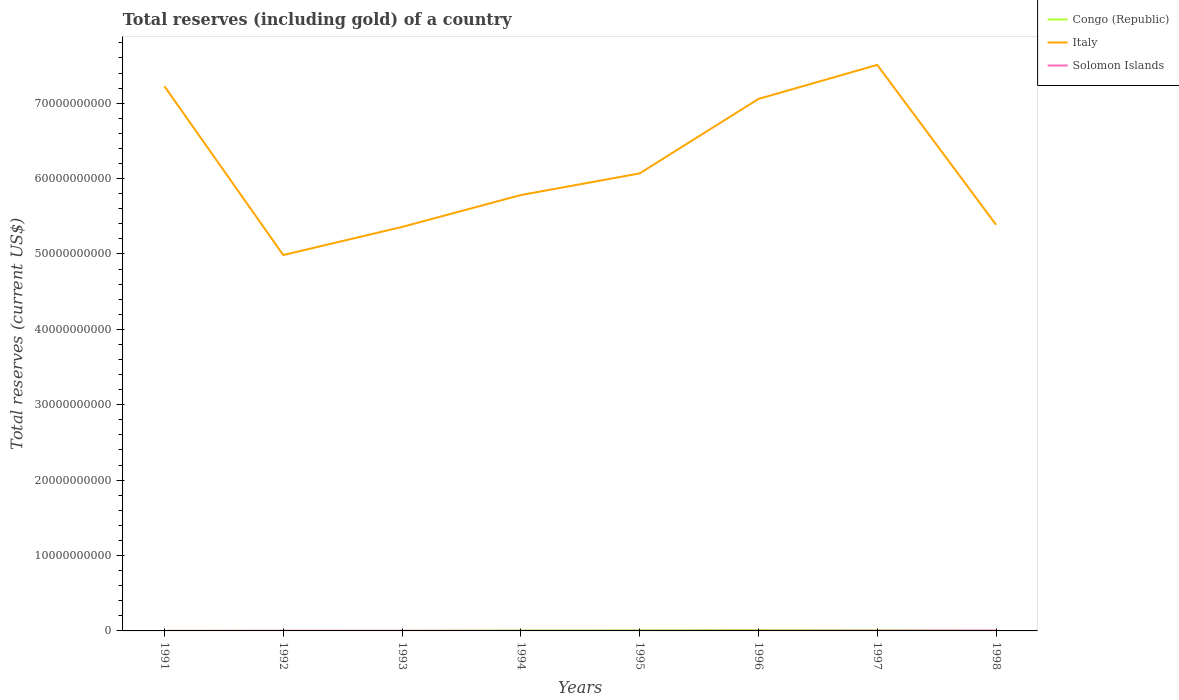Does the line corresponding to Italy intersect with the line corresponding to Solomon Islands?
Give a very brief answer. No. Is the number of lines equal to the number of legend labels?
Your answer should be compact. Yes. Across all years, what is the maximum total reserves (including gold) in Italy?
Your response must be concise. 4.99e+1. In which year was the total reserves (including gold) in Italy maximum?
Keep it short and to the point. 1992. What is the total total reserves (including gold) in Congo (Republic) in the graph?
Your answer should be very brief. -8.52e+06. What is the difference between the highest and the second highest total reserves (including gold) in Italy?
Provide a succinct answer. 2.52e+1. Is the total reserves (including gold) in Solomon Islands strictly greater than the total reserves (including gold) in Italy over the years?
Provide a short and direct response. Yes. How many lines are there?
Your answer should be compact. 3. Are the values on the major ticks of Y-axis written in scientific E-notation?
Provide a succinct answer. No. Where does the legend appear in the graph?
Offer a terse response. Top right. How many legend labels are there?
Your answer should be compact. 3. How are the legend labels stacked?
Keep it short and to the point. Vertical. What is the title of the graph?
Provide a short and direct response. Total reserves (including gold) of a country. What is the label or title of the X-axis?
Give a very brief answer. Years. What is the label or title of the Y-axis?
Your answer should be very brief. Total reserves (current US$). What is the Total reserves (current US$) of Congo (Republic) in 1991?
Offer a very short reply. 8.69e+06. What is the Total reserves (current US$) in Italy in 1991?
Your answer should be compact. 7.23e+1. What is the Total reserves (current US$) in Solomon Islands in 1991?
Offer a terse response. 8.54e+06. What is the Total reserves (current US$) of Congo (Republic) in 1992?
Your answer should be very brief. 7.71e+06. What is the Total reserves (current US$) of Italy in 1992?
Offer a very short reply. 4.99e+1. What is the Total reserves (current US$) of Solomon Islands in 1992?
Your response must be concise. 2.35e+07. What is the Total reserves (current US$) in Congo (Republic) in 1993?
Your answer should be compact. 5.68e+06. What is the Total reserves (current US$) of Italy in 1993?
Keep it short and to the point. 5.36e+1. What is the Total reserves (current US$) in Solomon Islands in 1993?
Offer a terse response. 2.01e+07. What is the Total reserves (current US$) in Congo (Republic) in 1994?
Your answer should be very brief. 5.46e+07. What is the Total reserves (current US$) in Italy in 1994?
Your answer should be compact. 5.78e+1. What is the Total reserves (current US$) of Solomon Islands in 1994?
Make the answer very short. 1.74e+07. What is the Total reserves (current US$) in Congo (Republic) in 1995?
Offer a terse response. 6.36e+07. What is the Total reserves (current US$) in Italy in 1995?
Give a very brief answer. 6.07e+1. What is the Total reserves (current US$) in Solomon Islands in 1995?
Your response must be concise. 1.59e+07. What is the Total reserves (current US$) of Congo (Republic) in 1996?
Your response must be concise. 9.51e+07. What is the Total reserves (current US$) in Italy in 1996?
Your response must be concise. 7.06e+1. What is the Total reserves (current US$) in Solomon Islands in 1996?
Provide a short and direct response. 3.26e+07. What is the Total reserves (current US$) of Congo (Republic) in 1997?
Give a very brief answer. 6.31e+07. What is the Total reserves (current US$) in Italy in 1997?
Provide a succinct answer. 7.51e+1. What is the Total reserves (current US$) of Solomon Islands in 1997?
Ensure brevity in your answer.  3.63e+07. What is the Total reserves (current US$) of Congo (Republic) in 1998?
Offer a very short reply. 4.04e+06. What is the Total reserves (current US$) in Italy in 1998?
Your answer should be compact. 5.39e+1. What is the Total reserves (current US$) of Solomon Islands in 1998?
Your answer should be very brief. 4.90e+07. Across all years, what is the maximum Total reserves (current US$) of Congo (Republic)?
Offer a terse response. 9.51e+07. Across all years, what is the maximum Total reserves (current US$) in Italy?
Ensure brevity in your answer.  7.51e+1. Across all years, what is the maximum Total reserves (current US$) in Solomon Islands?
Provide a short and direct response. 4.90e+07. Across all years, what is the minimum Total reserves (current US$) in Congo (Republic)?
Provide a short and direct response. 4.04e+06. Across all years, what is the minimum Total reserves (current US$) of Italy?
Provide a succinct answer. 4.99e+1. Across all years, what is the minimum Total reserves (current US$) of Solomon Islands?
Your answer should be compact. 8.54e+06. What is the total Total reserves (current US$) in Congo (Republic) in the graph?
Make the answer very short. 3.03e+08. What is the total Total reserves (current US$) in Italy in the graph?
Offer a terse response. 4.94e+11. What is the total Total reserves (current US$) in Solomon Islands in the graph?
Ensure brevity in your answer.  2.03e+08. What is the difference between the Total reserves (current US$) in Congo (Republic) in 1991 and that in 1992?
Provide a short and direct response. 9.80e+05. What is the difference between the Total reserves (current US$) in Italy in 1991 and that in 1992?
Make the answer very short. 2.24e+1. What is the difference between the Total reserves (current US$) of Solomon Islands in 1991 and that in 1992?
Provide a short and direct response. -1.50e+07. What is the difference between the Total reserves (current US$) of Congo (Republic) in 1991 and that in 1993?
Make the answer very short. 3.01e+06. What is the difference between the Total reserves (current US$) in Italy in 1991 and that in 1993?
Give a very brief answer. 1.87e+1. What is the difference between the Total reserves (current US$) in Solomon Islands in 1991 and that in 1993?
Give a very brief answer. -1.15e+07. What is the difference between the Total reserves (current US$) in Congo (Republic) in 1991 and that in 1994?
Your answer should be very brief. -4.59e+07. What is the difference between the Total reserves (current US$) of Italy in 1991 and that in 1994?
Your answer should be compact. 1.44e+1. What is the difference between the Total reserves (current US$) in Solomon Islands in 1991 and that in 1994?
Provide a short and direct response. -8.88e+06. What is the difference between the Total reserves (current US$) of Congo (Republic) in 1991 and that in 1995?
Provide a succinct answer. -5.49e+07. What is the difference between the Total reserves (current US$) of Italy in 1991 and that in 1995?
Make the answer very short. 1.16e+1. What is the difference between the Total reserves (current US$) of Solomon Islands in 1991 and that in 1995?
Offer a terse response. -7.36e+06. What is the difference between the Total reserves (current US$) in Congo (Republic) in 1991 and that in 1996?
Offer a very short reply. -8.64e+07. What is the difference between the Total reserves (current US$) in Italy in 1991 and that in 1996?
Ensure brevity in your answer.  1.69e+09. What is the difference between the Total reserves (current US$) of Solomon Islands in 1991 and that in 1996?
Keep it short and to the point. -2.40e+07. What is the difference between the Total reserves (current US$) in Congo (Republic) in 1991 and that in 1997?
Provide a succinct answer. -5.45e+07. What is the difference between the Total reserves (current US$) of Italy in 1991 and that in 1997?
Provide a short and direct response. -2.83e+09. What is the difference between the Total reserves (current US$) of Solomon Islands in 1991 and that in 1997?
Your answer should be very brief. -2.78e+07. What is the difference between the Total reserves (current US$) in Congo (Republic) in 1991 and that in 1998?
Offer a terse response. 4.65e+06. What is the difference between the Total reserves (current US$) of Italy in 1991 and that in 1998?
Make the answer very short. 1.84e+1. What is the difference between the Total reserves (current US$) in Solomon Islands in 1991 and that in 1998?
Your response must be concise. -4.05e+07. What is the difference between the Total reserves (current US$) in Congo (Republic) in 1992 and that in 1993?
Your answer should be compact. 2.03e+06. What is the difference between the Total reserves (current US$) of Italy in 1992 and that in 1993?
Your answer should be very brief. -3.73e+09. What is the difference between the Total reserves (current US$) in Solomon Islands in 1992 and that in 1993?
Offer a terse response. 3.43e+06. What is the difference between the Total reserves (current US$) in Congo (Republic) in 1992 and that in 1994?
Your answer should be compact. -4.69e+07. What is the difference between the Total reserves (current US$) in Italy in 1992 and that in 1994?
Your answer should be very brief. -7.96e+09. What is the difference between the Total reserves (current US$) of Solomon Islands in 1992 and that in 1994?
Offer a very short reply. 6.08e+06. What is the difference between the Total reserves (current US$) of Congo (Republic) in 1992 and that in 1995?
Provide a short and direct response. -5.59e+07. What is the difference between the Total reserves (current US$) in Italy in 1992 and that in 1995?
Provide a succinct answer. -1.08e+1. What is the difference between the Total reserves (current US$) of Solomon Islands in 1992 and that in 1995?
Offer a very short reply. 7.59e+06. What is the difference between the Total reserves (current US$) in Congo (Republic) in 1992 and that in 1996?
Your answer should be very brief. -8.74e+07. What is the difference between the Total reserves (current US$) in Italy in 1992 and that in 1996?
Keep it short and to the point. -2.07e+1. What is the difference between the Total reserves (current US$) of Solomon Islands in 1992 and that in 1996?
Give a very brief answer. -9.09e+06. What is the difference between the Total reserves (current US$) of Congo (Republic) in 1992 and that in 1997?
Offer a terse response. -5.54e+07. What is the difference between the Total reserves (current US$) of Italy in 1992 and that in 1997?
Make the answer very short. -2.52e+1. What is the difference between the Total reserves (current US$) of Solomon Islands in 1992 and that in 1997?
Offer a very short reply. -1.28e+07. What is the difference between the Total reserves (current US$) of Congo (Republic) in 1992 and that in 1998?
Make the answer very short. 3.67e+06. What is the difference between the Total reserves (current US$) in Italy in 1992 and that in 1998?
Your answer should be very brief. -4.02e+09. What is the difference between the Total reserves (current US$) of Solomon Islands in 1992 and that in 1998?
Offer a terse response. -2.55e+07. What is the difference between the Total reserves (current US$) of Congo (Republic) in 1993 and that in 1994?
Keep it short and to the point. -4.89e+07. What is the difference between the Total reserves (current US$) of Italy in 1993 and that in 1994?
Ensure brevity in your answer.  -4.23e+09. What is the difference between the Total reserves (current US$) of Solomon Islands in 1993 and that in 1994?
Give a very brief answer. 2.65e+06. What is the difference between the Total reserves (current US$) of Congo (Republic) in 1993 and that in 1995?
Your response must be concise. -5.79e+07. What is the difference between the Total reserves (current US$) in Italy in 1993 and that in 1995?
Offer a terse response. -7.10e+09. What is the difference between the Total reserves (current US$) in Solomon Islands in 1993 and that in 1995?
Give a very brief answer. 4.16e+06. What is the difference between the Total reserves (current US$) in Congo (Republic) in 1993 and that in 1996?
Keep it short and to the point. -8.94e+07. What is the difference between the Total reserves (current US$) of Italy in 1993 and that in 1996?
Your answer should be compact. -1.70e+1. What is the difference between the Total reserves (current US$) in Solomon Islands in 1993 and that in 1996?
Ensure brevity in your answer.  -1.25e+07. What is the difference between the Total reserves (current US$) in Congo (Republic) in 1993 and that in 1997?
Your answer should be compact. -5.75e+07. What is the difference between the Total reserves (current US$) in Italy in 1993 and that in 1997?
Your response must be concise. -2.15e+1. What is the difference between the Total reserves (current US$) of Solomon Islands in 1993 and that in 1997?
Your response must be concise. -1.63e+07. What is the difference between the Total reserves (current US$) in Congo (Republic) in 1993 and that in 1998?
Offer a very short reply. 1.64e+06. What is the difference between the Total reserves (current US$) of Italy in 1993 and that in 1998?
Your answer should be compact. -2.90e+08. What is the difference between the Total reserves (current US$) in Solomon Islands in 1993 and that in 1998?
Provide a short and direct response. -2.90e+07. What is the difference between the Total reserves (current US$) of Congo (Republic) in 1994 and that in 1995?
Give a very brief answer. -8.98e+06. What is the difference between the Total reserves (current US$) of Italy in 1994 and that in 1995?
Ensure brevity in your answer.  -2.87e+09. What is the difference between the Total reserves (current US$) of Solomon Islands in 1994 and that in 1995?
Provide a short and direct response. 1.51e+06. What is the difference between the Total reserves (current US$) in Congo (Republic) in 1994 and that in 1996?
Offer a very short reply. -4.05e+07. What is the difference between the Total reserves (current US$) of Italy in 1994 and that in 1996?
Offer a very short reply. -1.27e+1. What is the difference between the Total reserves (current US$) in Solomon Islands in 1994 and that in 1996?
Provide a short and direct response. -1.52e+07. What is the difference between the Total reserves (current US$) in Congo (Republic) in 1994 and that in 1997?
Offer a terse response. -8.52e+06. What is the difference between the Total reserves (current US$) of Italy in 1994 and that in 1997?
Keep it short and to the point. -1.73e+1. What is the difference between the Total reserves (current US$) of Solomon Islands in 1994 and that in 1997?
Offer a very short reply. -1.89e+07. What is the difference between the Total reserves (current US$) in Congo (Republic) in 1994 and that in 1998?
Provide a short and direct response. 5.06e+07. What is the difference between the Total reserves (current US$) of Italy in 1994 and that in 1998?
Keep it short and to the point. 3.94e+09. What is the difference between the Total reserves (current US$) of Solomon Islands in 1994 and that in 1998?
Your answer should be compact. -3.16e+07. What is the difference between the Total reserves (current US$) of Congo (Republic) in 1995 and that in 1996?
Your answer should be compact. -3.15e+07. What is the difference between the Total reserves (current US$) in Italy in 1995 and that in 1996?
Offer a terse response. -9.88e+09. What is the difference between the Total reserves (current US$) in Solomon Islands in 1995 and that in 1996?
Provide a succinct answer. -1.67e+07. What is the difference between the Total reserves (current US$) in Congo (Republic) in 1995 and that in 1997?
Your answer should be very brief. 4.56e+05. What is the difference between the Total reserves (current US$) of Italy in 1995 and that in 1997?
Give a very brief answer. -1.44e+1. What is the difference between the Total reserves (current US$) of Solomon Islands in 1995 and that in 1997?
Your response must be concise. -2.04e+07. What is the difference between the Total reserves (current US$) in Congo (Republic) in 1995 and that in 1998?
Your response must be concise. 5.96e+07. What is the difference between the Total reserves (current US$) in Italy in 1995 and that in 1998?
Your response must be concise. 6.81e+09. What is the difference between the Total reserves (current US$) of Solomon Islands in 1995 and that in 1998?
Offer a very short reply. -3.31e+07. What is the difference between the Total reserves (current US$) of Congo (Republic) in 1996 and that in 1997?
Keep it short and to the point. 3.20e+07. What is the difference between the Total reserves (current US$) in Italy in 1996 and that in 1997?
Offer a very short reply. -4.52e+09. What is the difference between the Total reserves (current US$) of Solomon Islands in 1996 and that in 1997?
Make the answer very short. -3.76e+06. What is the difference between the Total reserves (current US$) in Congo (Republic) in 1996 and that in 1998?
Offer a very short reply. 9.11e+07. What is the difference between the Total reserves (current US$) of Italy in 1996 and that in 1998?
Your answer should be very brief. 1.67e+1. What is the difference between the Total reserves (current US$) in Solomon Islands in 1996 and that in 1998?
Keep it short and to the point. -1.65e+07. What is the difference between the Total reserves (current US$) in Congo (Republic) in 1997 and that in 1998?
Provide a succinct answer. 5.91e+07. What is the difference between the Total reserves (current US$) of Italy in 1997 and that in 1998?
Ensure brevity in your answer.  2.12e+1. What is the difference between the Total reserves (current US$) of Solomon Islands in 1997 and that in 1998?
Your response must be concise. -1.27e+07. What is the difference between the Total reserves (current US$) in Congo (Republic) in 1991 and the Total reserves (current US$) in Italy in 1992?
Offer a very short reply. -4.99e+1. What is the difference between the Total reserves (current US$) in Congo (Republic) in 1991 and the Total reserves (current US$) in Solomon Islands in 1992?
Provide a short and direct response. -1.48e+07. What is the difference between the Total reserves (current US$) in Italy in 1991 and the Total reserves (current US$) in Solomon Islands in 1992?
Your answer should be compact. 7.22e+1. What is the difference between the Total reserves (current US$) in Congo (Republic) in 1991 and the Total reserves (current US$) in Italy in 1993?
Offer a terse response. -5.36e+1. What is the difference between the Total reserves (current US$) of Congo (Republic) in 1991 and the Total reserves (current US$) of Solomon Islands in 1993?
Ensure brevity in your answer.  -1.14e+07. What is the difference between the Total reserves (current US$) in Italy in 1991 and the Total reserves (current US$) in Solomon Islands in 1993?
Keep it short and to the point. 7.22e+1. What is the difference between the Total reserves (current US$) in Congo (Republic) in 1991 and the Total reserves (current US$) in Italy in 1994?
Your response must be concise. -5.78e+1. What is the difference between the Total reserves (current US$) in Congo (Republic) in 1991 and the Total reserves (current US$) in Solomon Islands in 1994?
Give a very brief answer. -8.72e+06. What is the difference between the Total reserves (current US$) of Italy in 1991 and the Total reserves (current US$) of Solomon Islands in 1994?
Your answer should be compact. 7.22e+1. What is the difference between the Total reserves (current US$) of Congo (Republic) in 1991 and the Total reserves (current US$) of Italy in 1995?
Provide a succinct answer. -6.07e+1. What is the difference between the Total reserves (current US$) of Congo (Republic) in 1991 and the Total reserves (current US$) of Solomon Islands in 1995?
Offer a terse response. -7.21e+06. What is the difference between the Total reserves (current US$) in Italy in 1991 and the Total reserves (current US$) in Solomon Islands in 1995?
Provide a succinct answer. 7.22e+1. What is the difference between the Total reserves (current US$) in Congo (Republic) in 1991 and the Total reserves (current US$) in Italy in 1996?
Make the answer very short. -7.06e+1. What is the difference between the Total reserves (current US$) in Congo (Republic) in 1991 and the Total reserves (current US$) in Solomon Islands in 1996?
Your response must be concise. -2.39e+07. What is the difference between the Total reserves (current US$) in Italy in 1991 and the Total reserves (current US$) in Solomon Islands in 1996?
Your answer should be very brief. 7.22e+1. What is the difference between the Total reserves (current US$) in Congo (Republic) in 1991 and the Total reserves (current US$) in Italy in 1997?
Give a very brief answer. -7.51e+1. What is the difference between the Total reserves (current US$) in Congo (Republic) in 1991 and the Total reserves (current US$) in Solomon Islands in 1997?
Your answer should be compact. -2.76e+07. What is the difference between the Total reserves (current US$) of Italy in 1991 and the Total reserves (current US$) of Solomon Islands in 1997?
Provide a succinct answer. 7.22e+1. What is the difference between the Total reserves (current US$) of Congo (Republic) in 1991 and the Total reserves (current US$) of Italy in 1998?
Your response must be concise. -5.39e+1. What is the difference between the Total reserves (current US$) in Congo (Republic) in 1991 and the Total reserves (current US$) in Solomon Islands in 1998?
Keep it short and to the point. -4.03e+07. What is the difference between the Total reserves (current US$) of Italy in 1991 and the Total reserves (current US$) of Solomon Islands in 1998?
Provide a succinct answer. 7.22e+1. What is the difference between the Total reserves (current US$) of Congo (Republic) in 1992 and the Total reserves (current US$) of Italy in 1993?
Keep it short and to the point. -5.36e+1. What is the difference between the Total reserves (current US$) in Congo (Republic) in 1992 and the Total reserves (current US$) in Solomon Islands in 1993?
Your response must be concise. -1.24e+07. What is the difference between the Total reserves (current US$) of Italy in 1992 and the Total reserves (current US$) of Solomon Islands in 1993?
Ensure brevity in your answer.  4.98e+1. What is the difference between the Total reserves (current US$) of Congo (Republic) in 1992 and the Total reserves (current US$) of Italy in 1994?
Your response must be concise. -5.78e+1. What is the difference between the Total reserves (current US$) in Congo (Republic) in 1992 and the Total reserves (current US$) in Solomon Islands in 1994?
Your response must be concise. -9.70e+06. What is the difference between the Total reserves (current US$) of Italy in 1992 and the Total reserves (current US$) of Solomon Islands in 1994?
Offer a very short reply. 4.98e+1. What is the difference between the Total reserves (current US$) of Congo (Republic) in 1992 and the Total reserves (current US$) of Italy in 1995?
Offer a terse response. -6.07e+1. What is the difference between the Total reserves (current US$) in Congo (Republic) in 1992 and the Total reserves (current US$) in Solomon Islands in 1995?
Ensure brevity in your answer.  -8.19e+06. What is the difference between the Total reserves (current US$) of Italy in 1992 and the Total reserves (current US$) of Solomon Islands in 1995?
Your response must be concise. 4.98e+1. What is the difference between the Total reserves (current US$) of Congo (Republic) in 1992 and the Total reserves (current US$) of Italy in 1996?
Make the answer very short. -7.06e+1. What is the difference between the Total reserves (current US$) of Congo (Republic) in 1992 and the Total reserves (current US$) of Solomon Islands in 1996?
Make the answer very short. -2.49e+07. What is the difference between the Total reserves (current US$) of Italy in 1992 and the Total reserves (current US$) of Solomon Islands in 1996?
Your answer should be very brief. 4.98e+1. What is the difference between the Total reserves (current US$) of Congo (Republic) in 1992 and the Total reserves (current US$) of Italy in 1997?
Keep it short and to the point. -7.51e+1. What is the difference between the Total reserves (current US$) of Congo (Republic) in 1992 and the Total reserves (current US$) of Solomon Islands in 1997?
Keep it short and to the point. -2.86e+07. What is the difference between the Total reserves (current US$) in Italy in 1992 and the Total reserves (current US$) in Solomon Islands in 1997?
Offer a very short reply. 4.98e+1. What is the difference between the Total reserves (current US$) of Congo (Republic) in 1992 and the Total reserves (current US$) of Italy in 1998?
Ensure brevity in your answer.  -5.39e+1. What is the difference between the Total reserves (current US$) in Congo (Republic) in 1992 and the Total reserves (current US$) in Solomon Islands in 1998?
Make the answer very short. -4.13e+07. What is the difference between the Total reserves (current US$) of Italy in 1992 and the Total reserves (current US$) of Solomon Islands in 1998?
Provide a short and direct response. 4.98e+1. What is the difference between the Total reserves (current US$) in Congo (Republic) in 1993 and the Total reserves (current US$) in Italy in 1994?
Your response must be concise. -5.78e+1. What is the difference between the Total reserves (current US$) in Congo (Republic) in 1993 and the Total reserves (current US$) in Solomon Islands in 1994?
Provide a short and direct response. -1.17e+07. What is the difference between the Total reserves (current US$) of Italy in 1993 and the Total reserves (current US$) of Solomon Islands in 1994?
Offer a very short reply. 5.36e+1. What is the difference between the Total reserves (current US$) in Congo (Republic) in 1993 and the Total reserves (current US$) in Italy in 1995?
Provide a short and direct response. -6.07e+1. What is the difference between the Total reserves (current US$) in Congo (Republic) in 1993 and the Total reserves (current US$) in Solomon Islands in 1995?
Your answer should be very brief. -1.02e+07. What is the difference between the Total reserves (current US$) in Italy in 1993 and the Total reserves (current US$) in Solomon Islands in 1995?
Your answer should be compact. 5.36e+1. What is the difference between the Total reserves (current US$) of Congo (Republic) in 1993 and the Total reserves (current US$) of Italy in 1996?
Your response must be concise. -7.06e+1. What is the difference between the Total reserves (current US$) of Congo (Republic) in 1993 and the Total reserves (current US$) of Solomon Islands in 1996?
Provide a short and direct response. -2.69e+07. What is the difference between the Total reserves (current US$) of Italy in 1993 and the Total reserves (current US$) of Solomon Islands in 1996?
Your answer should be compact. 5.36e+1. What is the difference between the Total reserves (current US$) in Congo (Republic) in 1993 and the Total reserves (current US$) in Italy in 1997?
Make the answer very short. -7.51e+1. What is the difference between the Total reserves (current US$) in Congo (Republic) in 1993 and the Total reserves (current US$) in Solomon Islands in 1997?
Offer a very short reply. -3.07e+07. What is the difference between the Total reserves (current US$) of Italy in 1993 and the Total reserves (current US$) of Solomon Islands in 1997?
Your answer should be very brief. 5.36e+1. What is the difference between the Total reserves (current US$) of Congo (Republic) in 1993 and the Total reserves (current US$) of Italy in 1998?
Provide a short and direct response. -5.39e+1. What is the difference between the Total reserves (current US$) in Congo (Republic) in 1993 and the Total reserves (current US$) in Solomon Islands in 1998?
Your response must be concise. -4.34e+07. What is the difference between the Total reserves (current US$) of Italy in 1993 and the Total reserves (current US$) of Solomon Islands in 1998?
Provide a short and direct response. 5.35e+1. What is the difference between the Total reserves (current US$) in Congo (Republic) in 1994 and the Total reserves (current US$) in Italy in 1995?
Offer a terse response. -6.06e+1. What is the difference between the Total reserves (current US$) of Congo (Republic) in 1994 and the Total reserves (current US$) of Solomon Islands in 1995?
Ensure brevity in your answer.  3.87e+07. What is the difference between the Total reserves (current US$) in Italy in 1994 and the Total reserves (current US$) in Solomon Islands in 1995?
Your response must be concise. 5.78e+1. What is the difference between the Total reserves (current US$) in Congo (Republic) in 1994 and the Total reserves (current US$) in Italy in 1996?
Offer a very short reply. -7.05e+1. What is the difference between the Total reserves (current US$) in Congo (Republic) in 1994 and the Total reserves (current US$) in Solomon Islands in 1996?
Offer a very short reply. 2.20e+07. What is the difference between the Total reserves (current US$) in Italy in 1994 and the Total reserves (current US$) in Solomon Islands in 1996?
Offer a very short reply. 5.78e+1. What is the difference between the Total reserves (current US$) of Congo (Republic) in 1994 and the Total reserves (current US$) of Italy in 1997?
Offer a very short reply. -7.50e+1. What is the difference between the Total reserves (current US$) of Congo (Republic) in 1994 and the Total reserves (current US$) of Solomon Islands in 1997?
Offer a very short reply. 1.83e+07. What is the difference between the Total reserves (current US$) of Italy in 1994 and the Total reserves (current US$) of Solomon Islands in 1997?
Give a very brief answer. 5.78e+1. What is the difference between the Total reserves (current US$) in Congo (Republic) in 1994 and the Total reserves (current US$) in Italy in 1998?
Provide a short and direct response. -5.38e+1. What is the difference between the Total reserves (current US$) of Congo (Republic) in 1994 and the Total reserves (current US$) of Solomon Islands in 1998?
Your response must be concise. 5.59e+06. What is the difference between the Total reserves (current US$) in Italy in 1994 and the Total reserves (current US$) in Solomon Islands in 1998?
Provide a succinct answer. 5.78e+1. What is the difference between the Total reserves (current US$) in Congo (Republic) in 1995 and the Total reserves (current US$) in Italy in 1996?
Keep it short and to the point. -7.05e+1. What is the difference between the Total reserves (current US$) in Congo (Republic) in 1995 and the Total reserves (current US$) in Solomon Islands in 1996?
Give a very brief answer. 3.10e+07. What is the difference between the Total reserves (current US$) of Italy in 1995 and the Total reserves (current US$) of Solomon Islands in 1996?
Ensure brevity in your answer.  6.07e+1. What is the difference between the Total reserves (current US$) of Congo (Republic) in 1995 and the Total reserves (current US$) of Italy in 1997?
Make the answer very short. -7.50e+1. What is the difference between the Total reserves (current US$) of Congo (Republic) in 1995 and the Total reserves (current US$) of Solomon Islands in 1997?
Your response must be concise. 2.73e+07. What is the difference between the Total reserves (current US$) of Italy in 1995 and the Total reserves (current US$) of Solomon Islands in 1997?
Provide a short and direct response. 6.07e+1. What is the difference between the Total reserves (current US$) of Congo (Republic) in 1995 and the Total reserves (current US$) of Italy in 1998?
Your response must be concise. -5.38e+1. What is the difference between the Total reserves (current US$) in Congo (Republic) in 1995 and the Total reserves (current US$) in Solomon Islands in 1998?
Ensure brevity in your answer.  1.46e+07. What is the difference between the Total reserves (current US$) in Italy in 1995 and the Total reserves (current US$) in Solomon Islands in 1998?
Ensure brevity in your answer.  6.06e+1. What is the difference between the Total reserves (current US$) of Congo (Republic) in 1996 and the Total reserves (current US$) of Italy in 1997?
Your answer should be very brief. -7.50e+1. What is the difference between the Total reserves (current US$) in Congo (Republic) in 1996 and the Total reserves (current US$) in Solomon Islands in 1997?
Ensure brevity in your answer.  5.88e+07. What is the difference between the Total reserves (current US$) in Italy in 1996 and the Total reserves (current US$) in Solomon Islands in 1997?
Your answer should be compact. 7.05e+1. What is the difference between the Total reserves (current US$) in Congo (Republic) in 1996 and the Total reserves (current US$) in Italy in 1998?
Provide a succinct answer. -5.38e+1. What is the difference between the Total reserves (current US$) of Congo (Republic) in 1996 and the Total reserves (current US$) of Solomon Islands in 1998?
Give a very brief answer. 4.61e+07. What is the difference between the Total reserves (current US$) in Italy in 1996 and the Total reserves (current US$) in Solomon Islands in 1998?
Give a very brief answer. 7.05e+1. What is the difference between the Total reserves (current US$) of Congo (Republic) in 1997 and the Total reserves (current US$) of Italy in 1998?
Make the answer very short. -5.38e+1. What is the difference between the Total reserves (current US$) of Congo (Republic) in 1997 and the Total reserves (current US$) of Solomon Islands in 1998?
Provide a succinct answer. 1.41e+07. What is the difference between the Total reserves (current US$) of Italy in 1997 and the Total reserves (current US$) of Solomon Islands in 1998?
Keep it short and to the point. 7.50e+1. What is the average Total reserves (current US$) of Congo (Republic) per year?
Your answer should be compact. 3.78e+07. What is the average Total reserves (current US$) of Italy per year?
Offer a very short reply. 6.17e+1. What is the average Total reserves (current US$) of Solomon Islands per year?
Provide a succinct answer. 2.54e+07. In the year 1991, what is the difference between the Total reserves (current US$) in Congo (Republic) and Total reserves (current US$) in Italy?
Your answer should be compact. -7.22e+1. In the year 1991, what is the difference between the Total reserves (current US$) in Congo (Republic) and Total reserves (current US$) in Solomon Islands?
Offer a terse response. 1.52e+05. In the year 1991, what is the difference between the Total reserves (current US$) in Italy and Total reserves (current US$) in Solomon Islands?
Your answer should be compact. 7.22e+1. In the year 1992, what is the difference between the Total reserves (current US$) in Congo (Republic) and Total reserves (current US$) in Italy?
Ensure brevity in your answer.  -4.99e+1. In the year 1992, what is the difference between the Total reserves (current US$) of Congo (Republic) and Total reserves (current US$) of Solomon Islands?
Keep it short and to the point. -1.58e+07. In the year 1992, what is the difference between the Total reserves (current US$) in Italy and Total reserves (current US$) in Solomon Islands?
Your answer should be very brief. 4.98e+1. In the year 1993, what is the difference between the Total reserves (current US$) in Congo (Republic) and Total reserves (current US$) in Italy?
Your response must be concise. -5.36e+1. In the year 1993, what is the difference between the Total reserves (current US$) in Congo (Republic) and Total reserves (current US$) in Solomon Islands?
Provide a short and direct response. -1.44e+07. In the year 1993, what is the difference between the Total reserves (current US$) of Italy and Total reserves (current US$) of Solomon Islands?
Ensure brevity in your answer.  5.36e+1. In the year 1994, what is the difference between the Total reserves (current US$) of Congo (Republic) and Total reserves (current US$) of Italy?
Make the answer very short. -5.78e+1. In the year 1994, what is the difference between the Total reserves (current US$) in Congo (Republic) and Total reserves (current US$) in Solomon Islands?
Offer a very short reply. 3.72e+07. In the year 1994, what is the difference between the Total reserves (current US$) in Italy and Total reserves (current US$) in Solomon Islands?
Offer a very short reply. 5.78e+1. In the year 1995, what is the difference between the Total reserves (current US$) of Congo (Republic) and Total reserves (current US$) of Italy?
Make the answer very short. -6.06e+1. In the year 1995, what is the difference between the Total reserves (current US$) of Congo (Republic) and Total reserves (current US$) of Solomon Islands?
Your answer should be very brief. 4.77e+07. In the year 1995, what is the difference between the Total reserves (current US$) in Italy and Total reserves (current US$) in Solomon Islands?
Provide a short and direct response. 6.07e+1. In the year 1996, what is the difference between the Total reserves (current US$) of Congo (Republic) and Total reserves (current US$) of Italy?
Your answer should be very brief. -7.05e+1. In the year 1996, what is the difference between the Total reserves (current US$) in Congo (Republic) and Total reserves (current US$) in Solomon Islands?
Provide a short and direct response. 6.25e+07. In the year 1996, what is the difference between the Total reserves (current US$) of Italy and Total reserves (current US$) of Solomon Islands?
Offer a terse response. 7.05e+1. In the year 1997, what is the difference between the Total reserves (current US$) of Congo (Republic) and Total reserves (current US$) of Italy?
Make the answer very short. -7.50e+1. In the year 1997, what is the difference between the Total reserves (current US$) in Congo (Republic) and Total reserves (current US$) in Solomon Islands?
Offer a very short reply. 2.68e+07. In the year 1997, what is the difference between the Total reserves (current US$) in Italy and Total reserves (current US$) in Solomon Islands?
Provide a succinct answer. 7.51e+1. In the year 1998, what is the difference between the Total reserves (current US$) in Congo (Republic) and Total reserves (current US$) in Italy?
Provide a succinct answer. -5.39e+1. In the year 1998, what is the difference between the Total reserves (current US$) in Congo (Republic) and Total reserves (current US$) in Solomon Islands?
Your answer should be very brief. -4.50e+07. In the year 1998, what is the difference between the Total reserves (current US$) of Italy and Total reserves (current US$) of Solomon Islands?
Your answer should be compact. 5.38e+1. What is the ratio of the Total reserves (current US$) of Congo (Republic) in 1991 to that in 1992?
Provide a succinct answer. 1.13. What is the ratio of the Total reserves (current US$) of Italy in 1991 to that in 1992?
Provide a short and direct response. 1.45. What is the ratio of the Total reserves (current US$) of Solomon Islands in 1991 to that in 1992?
Your answer should be compact. 0.36. What is the ratio of the Total reserves (current US$) of Congo (Republic) in 1991 to that in 1993?
Your response must be concise. 1.53. What is the ratio of the Total reserves (current US$) in Italy in 1991 to that in 1993?
Ensure brevity in your answer.  1.35. What is the ratio of the Total reserves (current US$) of Solomon Islands in 1991 to that in 1993?
Provide a short and direct response. 0.43. What is the ratio of the Total reserves (current US$) in Congo (Republic) in 1991 to that in 1994?
Make the answer very short. 0.16. What is the ratio of the Total reserves (current US$) of Italy in 1991 to that in 1994?
Give a very brief answer. 1.25. What is the ratio of the Total reserves (current US$) in Solomon Islands in 1991 to that in 1994?
Your answer should be compact. 0.49. What is the ratio of the Total reserves (current US$) in Congo (Republic) in 1991 to that in 1995?
Your response must be concise. 0.14. What is the ratio of the Total reserves (current US$) in Italy in 1991 to that in 1995?
Make the answer very short. 1.19. What is the ratio of the Total reserves (current US$) in Solomon Islands in 1991 to that in 1995?
Offer a very short reply. 0.54. What is the ratio of the Total reserves (current US$) in Congo (Republic) in 1991 to that in 1996?
Offer a very short reply. 0.09. What is the ratio of the Total reserves (current US$) of Italy in 1991 to that in 1996?
Your answer should be very brief. 1.02. What is the ratio of the Total reserves (current US$) in Solomon Islands in 1991 to that in 1996?
Your answer should be very brief. 0.26. What is the ratio of the Total reserves (current US$) in Congo (Republic) in 1991 to that in 1997?
Provide a succinct answer. 0.14. What is the ratio of the Total reserves (current US$) in Italy in 1991 to that in 1997?
Provide a short and direct response. 0.96. What is the ratio of the Total reserves (current US$) in Solomon Islands in 1991 to that in 1997?
Ensure brevity in your answer.  0.24. What is the ratio of the Total reserves (current US$) in Congo (Republic) in 1991 to that in 1998?
Give a very brief answer. 2.15. What is the ratio of the Total reserves (current US$) in Italy in 1991 to that in 1998?
Keep it short and to the point. 1.34. What is the ratio of the Total reserves (current US$) of Solomon Islands in 1991 to that in 1998?
Your response must be concise. 0.17. What is the ratio of the Total reserves (current US$) of Congo (Republic) in 1992 to that in 1993?
Offer a very short reply. 1.36. What is the ratio of the Total reserves (current US$) in Italy in 1992 to that in 1993?
Give a very brief answer. 0.93. What is the ratio of the Total reserves (current US$) of Solomon Islands in 1992 to that in 1993?
Make the answer very short. 1.17. What is the ratio of the Total reserves (current US$) of Congo (Republic) in 1992 to that in 1994?
Make the answer very short. 0.14. What is the ratio of the Total reserves (current US$) of Italy in 1992 to that in 1994?
Give a very brief answer. 0.86. What is the ratio of the Total reserves (current US$) in Solomon Islands in 1992 to that in 1994?
Your response must be concise. 1.35. What is the ratio of the Total reserves (current US$) in Congo (Republic) in 1992 to that in 1995?
Your answer should be very brief. 0.12. What is the ratio of the Total reserves (current US$) of Italy in 1992 to that in 1995?
Provide a short and direct response. 0.82. What is the ratio of the Total reserves (current US$) in Solomon Islands in 1992 to that in 1995?
Provide a succinct answer. 1.48. What is the ratio of the Total reserves (current US$) of Congo (Republic) in 1992 to that in 1996?
Give a very brief answer. 0.08. What is the ratio of the Total reserves (current US$) of Italy in 1992 to that in 1996?
Make the answer very short. 0.71. What is the ratio of the Total reserves (current US$) in Solomon Islands in 1992 to that in 1996?
Offer a terse response. 0.72. What is the ratio of the Total reserves (current US$) in Congo (Republic) in 1992 to that in 1997?
Your answer should be very brief. 0.12. What is the ratio of the Total reserves (current US$) in Italy in 1992 to that in 1997?
Make the answer very short. 0.66. What is the ratio of the Total reserves (current US$) of Solomon Islands in 1992 to that in 1997?
Give a very brief answer. 0.65. What is the ratio of the Total reserves (current US$) of Congo (Republic) in 1992 to that in 1998?
Provide a short and direct response. 1.91. What is the ratio of the Total reserves (current US$) of Italy in 1992 to that in 1998?
Offer a very short reply. 0.93. What is the ratio of the Total reserves (current US$) in Solomon Islands in 1992 to that in 1998?
Keep it short and to the point. 0.48. What is the ratio of the Total reserves (current US$) of Congo (Republic) in 1993 to that in 1994?
Your answer should be very brief. 0.1. What is the ratio of the Total reserves (current US$) in Italy in 1993 to that in 1994?
Make the answer very short. 0.93. What is the ratio of the Total reserves (current US$) in Solomon Islands in 1993 to that in 1994?
Keep it short and to the point. 1.15. What is the ratio of the Total reserves (current US$) in Congo (Republic) in 1993 to that in 1995?
Provide a succinct answer. 0.09. What is the ratio of the Total reserves (current US$) of Italy in 1993 to that in 1995?
Make the answer very short. 0.88. What is the ratio of the Total reserves (current US$) in Solomon Islands in 1993 to that in 1995?
Provide a succinct answer. 1.26. What is the ratio of the Total reserves (current US$) of Congo (Republic) in 1993 to that in 1996?
Make the answer very short. 0.06. What is the ratio of the Total reserves (current US$) of Italy in 1993 to that in 1996?
Provide a succinct answer. 0.76. What is the ratio of the Total reserves (current US$) of Solomon Islands in 1993 to that in 1996?
Offer a terse response. 0.62. What is the ratio of the Total reserves (current US$) in Congo (Republic) in 1993 to that in 1997?
Keep it short and to the point. 0.09. What is the ratio of the Total reserves (current US$) in Italy in 1993 to that in 1997?
Give a very brief answer. 0.71. What is the ratio of the Total reserves (current US$) in Solomon Islands in 1993 to that in 1997?
Offer a terse response. 0.55. What is the ratio of the Total reserves (current US$) of Congo (Republic) in 1993 to that in 1998?
Provide a short and direct response. 1.41. What is the ratio of the Total reserves (current US$) in Italy in 1993 to that in 1998?
Provide a short and direct response. 0.99. What is the ratio of the Total reserves (current US$) in Solomon Islands in 1993 to that in 1998?
Ensure brevity in your answer.  0.41. What is the ratio of the Total reserves (current US$) in Congo (Republic) in 1994 to that in 1995?
Provide a succinct answer. 0.86. What is the ratio of the Total reserves (current US$) in Italy in 1994 to that in 1995?
Your response must be concise. 0.95. What is the ratio of the Total reserves (current US$) in Solomon Islands in 1994 to that in 1995?
Provide a short and direct response. 1.1. What is the ratio of the Total reserves (current US$) of Congo (Republic) in 1994 to that in 1996?
Provide a short and direct response. 0.57. What is the ratio of the Total reserves (current US$) in Italy in 1994 to that in 1996?
Offer a very short reply. 0.82. What is the ratio of the Total reserves (current US$) of Solomon Islands in 1994 to that in 1996?
Your response must be concise. 0.53. What is the ratio of the Total reserves (current US$) in Congo (Republic) in 1994 to that in 1997?
Ensure brevity in your answer.  0.86. What is the ratio of the Total reserves (current US$) in Italy in 1994 to that in 1997?
Your answer should be compact. 0.77. What is the ratio of the Total reserves (current US$) in Solomon Islands in 1994 to that in 1997?
Keep it short and to the point. 0.48. What is the ratio of the Total reserves (current US$) in Congo (Republic) in 1994 to that in 1998?
Ensure brevity in your answer.  13.51. What is the ratio of the Total reserves (current US$) in Italy in 1994 to that in 1998?
Keep it short and to the point. 1.07. What is the ratio of the Total reserves (current US$) in Solomon Islands in 1994 to that in 1998?
Ensure brevity in your answer.  0.36. What is the ratio of the Total reserves (current US$) in Congo (Republic) in 1995 to that in 1996?
Your response must be concise. 0.67. What is the ratio of the Total reserves (current US$) in Italy in 1995 to that in 1996?
Offer a very short reply. 0.86. What is the ratio of the Total reserves (current US$) in Solomon Islands in 1995 to that in 1996?
Give a very brief answer. 0.49. What is the ratio of the Total reserves (current US$) of Italy in 1995 to that in 1997?
Your answer should be compact. 0.81. What is the ratio of the Total reserves (current US$) in Solomon Islands in 1995 to that in 1997?
Offer a very short reply. 0.44. What is the ratio of the Total reserves (current US$) in Congo (Republic) in 1995 to that in 1998?
Provide a succinct answer. 15.73. What is the ratio of the Total reserves (current US$) of Italy in 1995 to that in 1998?
Provide a succinct answer. 1.13. What is the ratio of the Total reserves (current US$) in Solomon Islands in 1995 to that in 1998?
Offer a very short reply. 0.32. What is the ratio of the Total reserves (current US$) in Congo (Republic) in 1996 to that in 1997?
Your response must be concise. 1.51. What is the ratio of the Total reserves (current US$) of Italy in 1996 to that in 1997?
Offer a very short reply. 0.94. What is the ratio of the Total reserves (current US$) in Solomon Islands in 1996 to that in 1997?
Ensure brevity in your answer.  0.9. What is the ratio of the Total reserves (current US$) of Congo (Republic) in 1996 to that in 1998?
Offer a very short reply. 23.52. What is the ratio of the Total reserves (current US$) in Italy in 1996 to that in 1998?
Your answer should be compact. 1.31. What is the ratio of the Total reserves (current US$) of Solomon Islands in 1996 to that in 1998?
Provide a short and direct response. 0.66. What is the ratio of the Total reserves (current US$) of Congo (Republic) in 1997 to that in 1998?
Give a very brief answer. 15.62. What is the ratio of the Total reserves (current US$) of Italy in 1997 to that in 1998?
Keep it short and to the point. 1.39. What is the ratio of the Total reserves (current US$) in Solomon Islands in 1997 to that in 1998?
Provide a short and direct response. 0.74. What is the difference between the highest and the second highest Total reserves (current US$) in Congo (Republic)?
Your answer should be compact. 3.15e+07. What is the difference between the highest and the second highest Total reserves (current US$) in Italy?
Ensure brevity in your answer.  2.83e+09. What is the difference between the highest and the second highest Total reserves (current US$) in Solomon Islands?
Give a very brief answer. 1.27e+07. What is the difference between the highest and the lowest Total reserves (current US$) of Congo (Republic)?
Give a very brief answer. 9.11e+07. What is the difference between the highest and the lowest Total reserves (current US$) in Italy?
Keep it short and to the point. 2.52e+1. What is the difference between the highest and the lowest Total reserves (current US$) of Solomon Islands?
Your answer should be compact. 4.05e+07. 